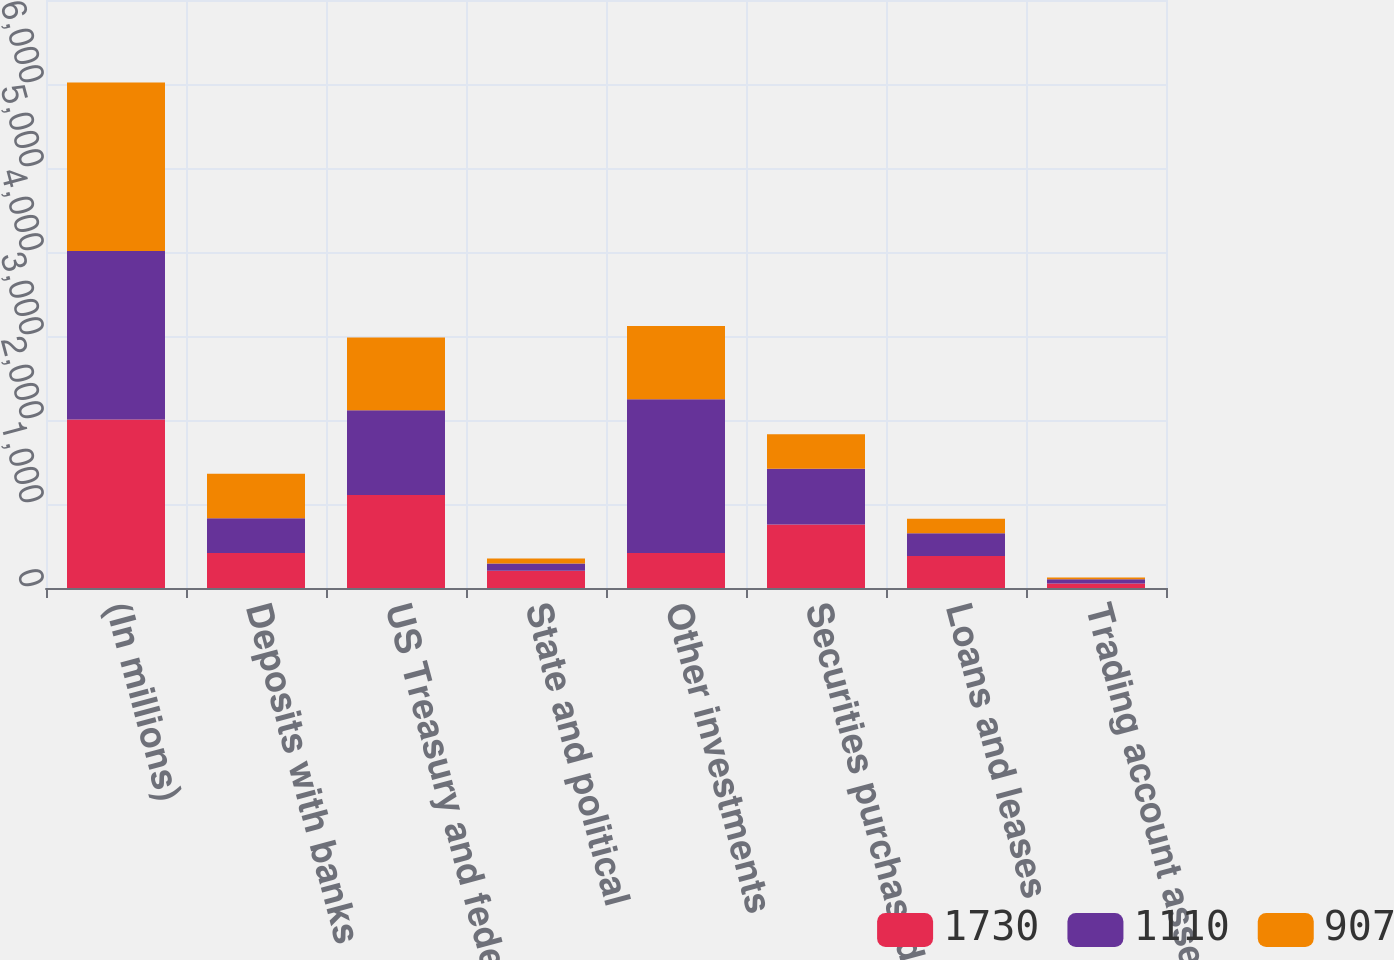Convert chart. <chart><loc_0><loc_0><loc_500><loc_500><stacked_bar_chart><ecel><fcel>(In millions)<fcel>Deposits with banks<fcel>US Treasury and federal<fcel>State and political<fcel>Other investments<fcel>Securities purchased under<fcel>Loans and leases<fcel>Trading account assets<nl><fcel>1730<fcel>2007<fcel>416<fcel>1106<fcel>205<fcel>416<fcel>756<fcel>382<fcel>55<nl><fcel>1110<fcel>2006<fcel>414<fcel>1011<fcel>88<fcel>1830<fcel>663<fcel>270<fcel>48<nl><fcel>907<fcel>2005<fcel>529<fcel>866<fcel>58<fcel>873<fcel>412<fcel>171<fcel>21<nl></chart> 